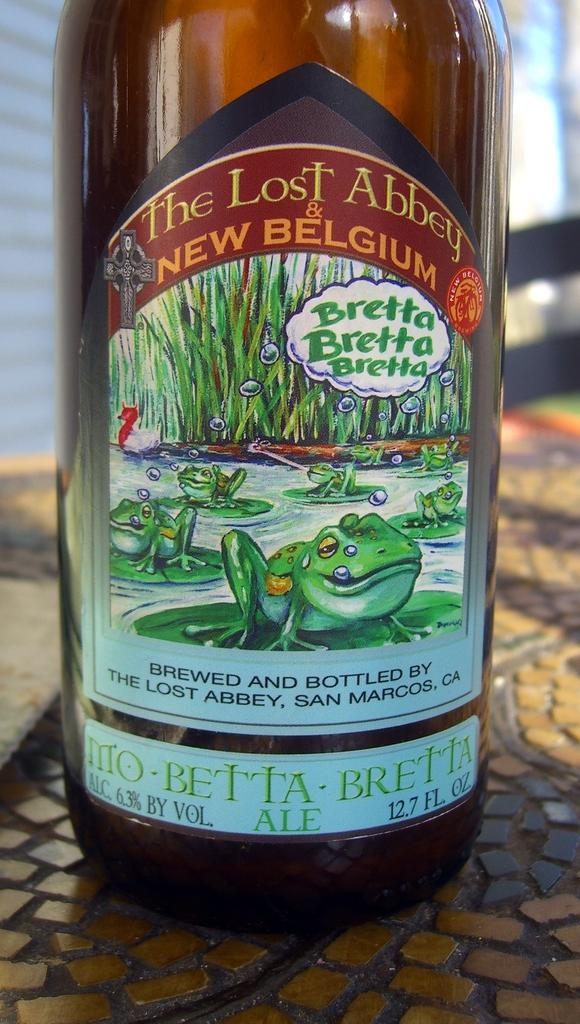<image>
Share a concise interpretation of the image provided. A bottle of the Lost Abbey wine sits on a table. 